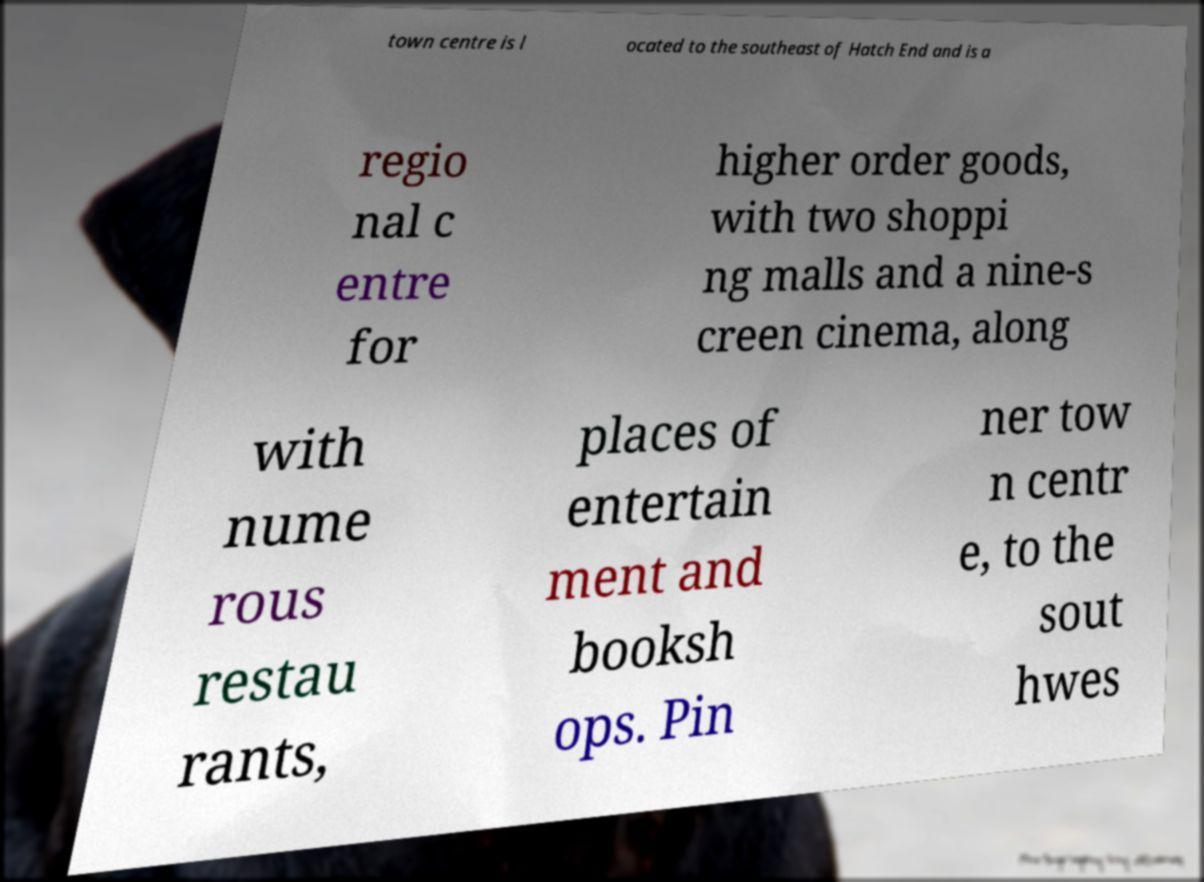What messages or text are displayed in this image? I need them in a readable, typed format. town centre is l ocated to the southeast of Hatch End and is a regio nal c entre for higher order goods, with two shoppi ng malls and a nine-s creen cinema, along with nume rous restau rants, places of entertain ment and booksh ops. Pin ner tow n centr e, to the sout hwes 